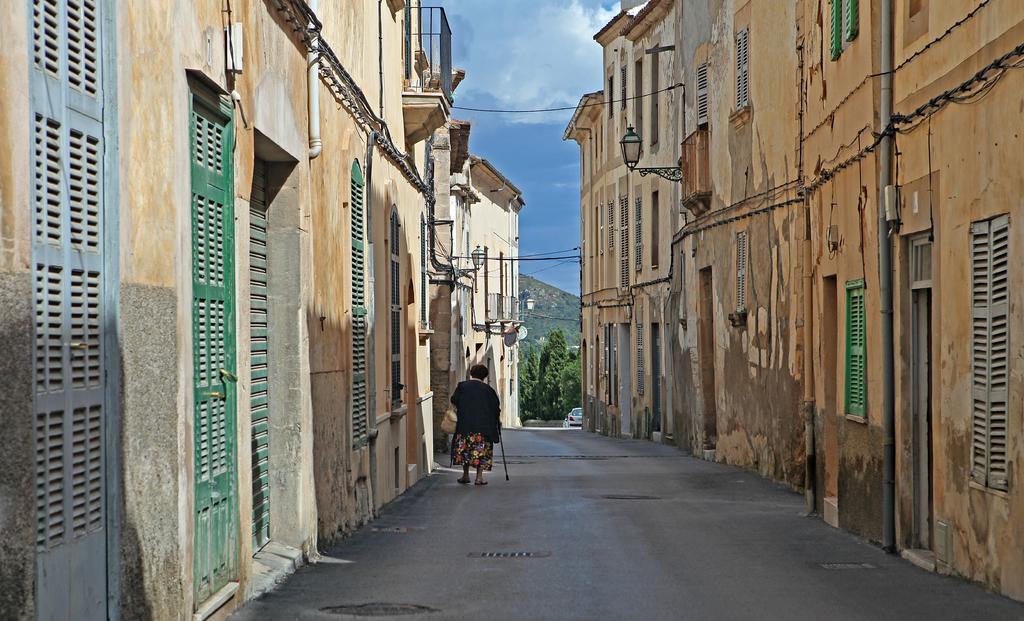Could you give a brief overview of what you see in this image? It is a street and on the either side of the road there are plenty of houses and there is a woman walking on the road. She is wearing a bag and she is holding a stick in her another hand. In the background there is a mountain and some trees. 